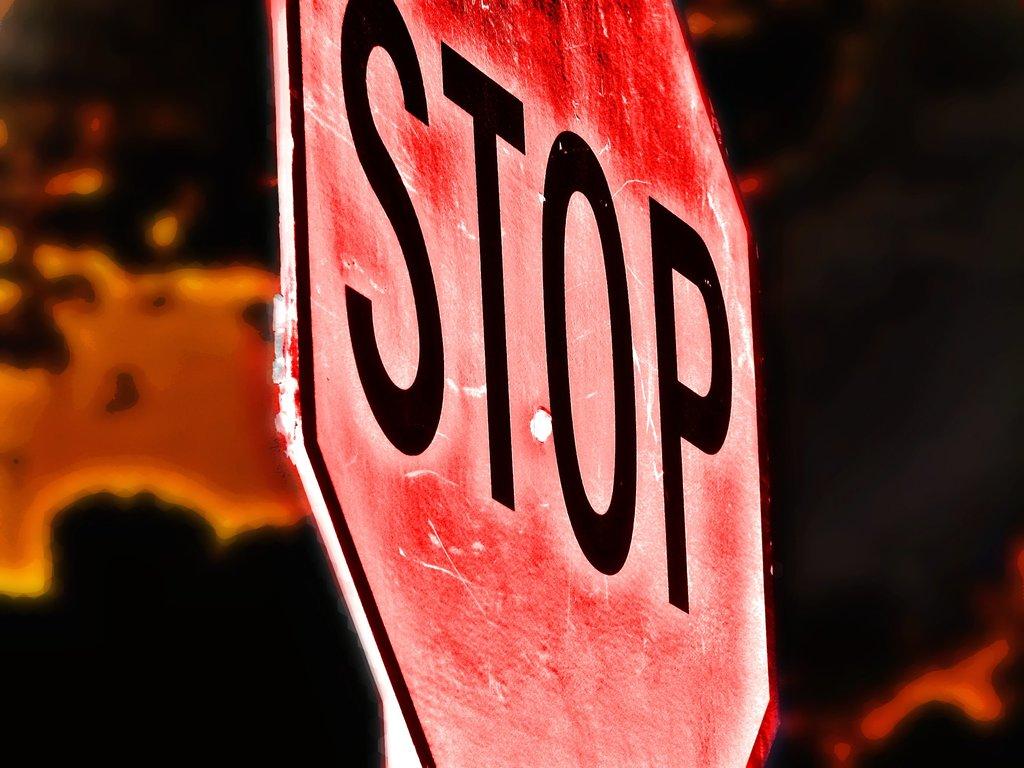What is on the sogn?
Offer a terse response. Stop. 